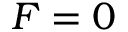<formula> <loc_0><loc_0><loc_500><loc_500>F = 0</formula> 